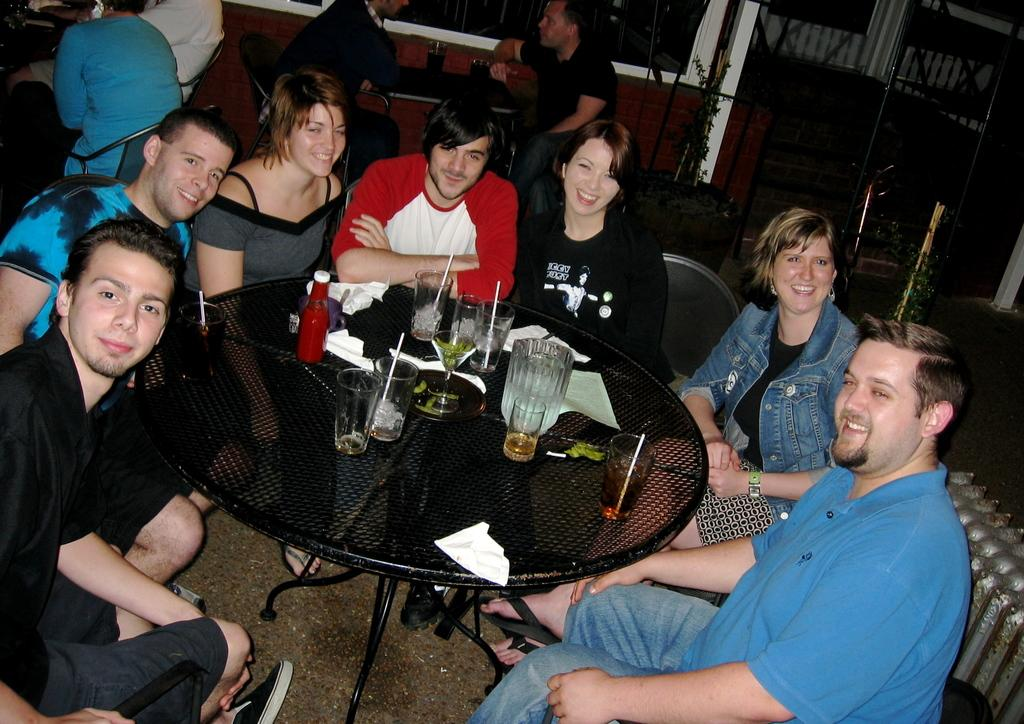What are the people in the image doing? The people in the image are sitting on chairs. What furniture is visible in the image besides the chairs? There are tables in the image. What can be found on the tables? Glasses and tissues are on the tables, along with other objects. What type of harmony is being played on the tables in the image? There is no indication of any musical instruments or sounds in the image, so it cannot be determined if any harmony is being played on the tables. 